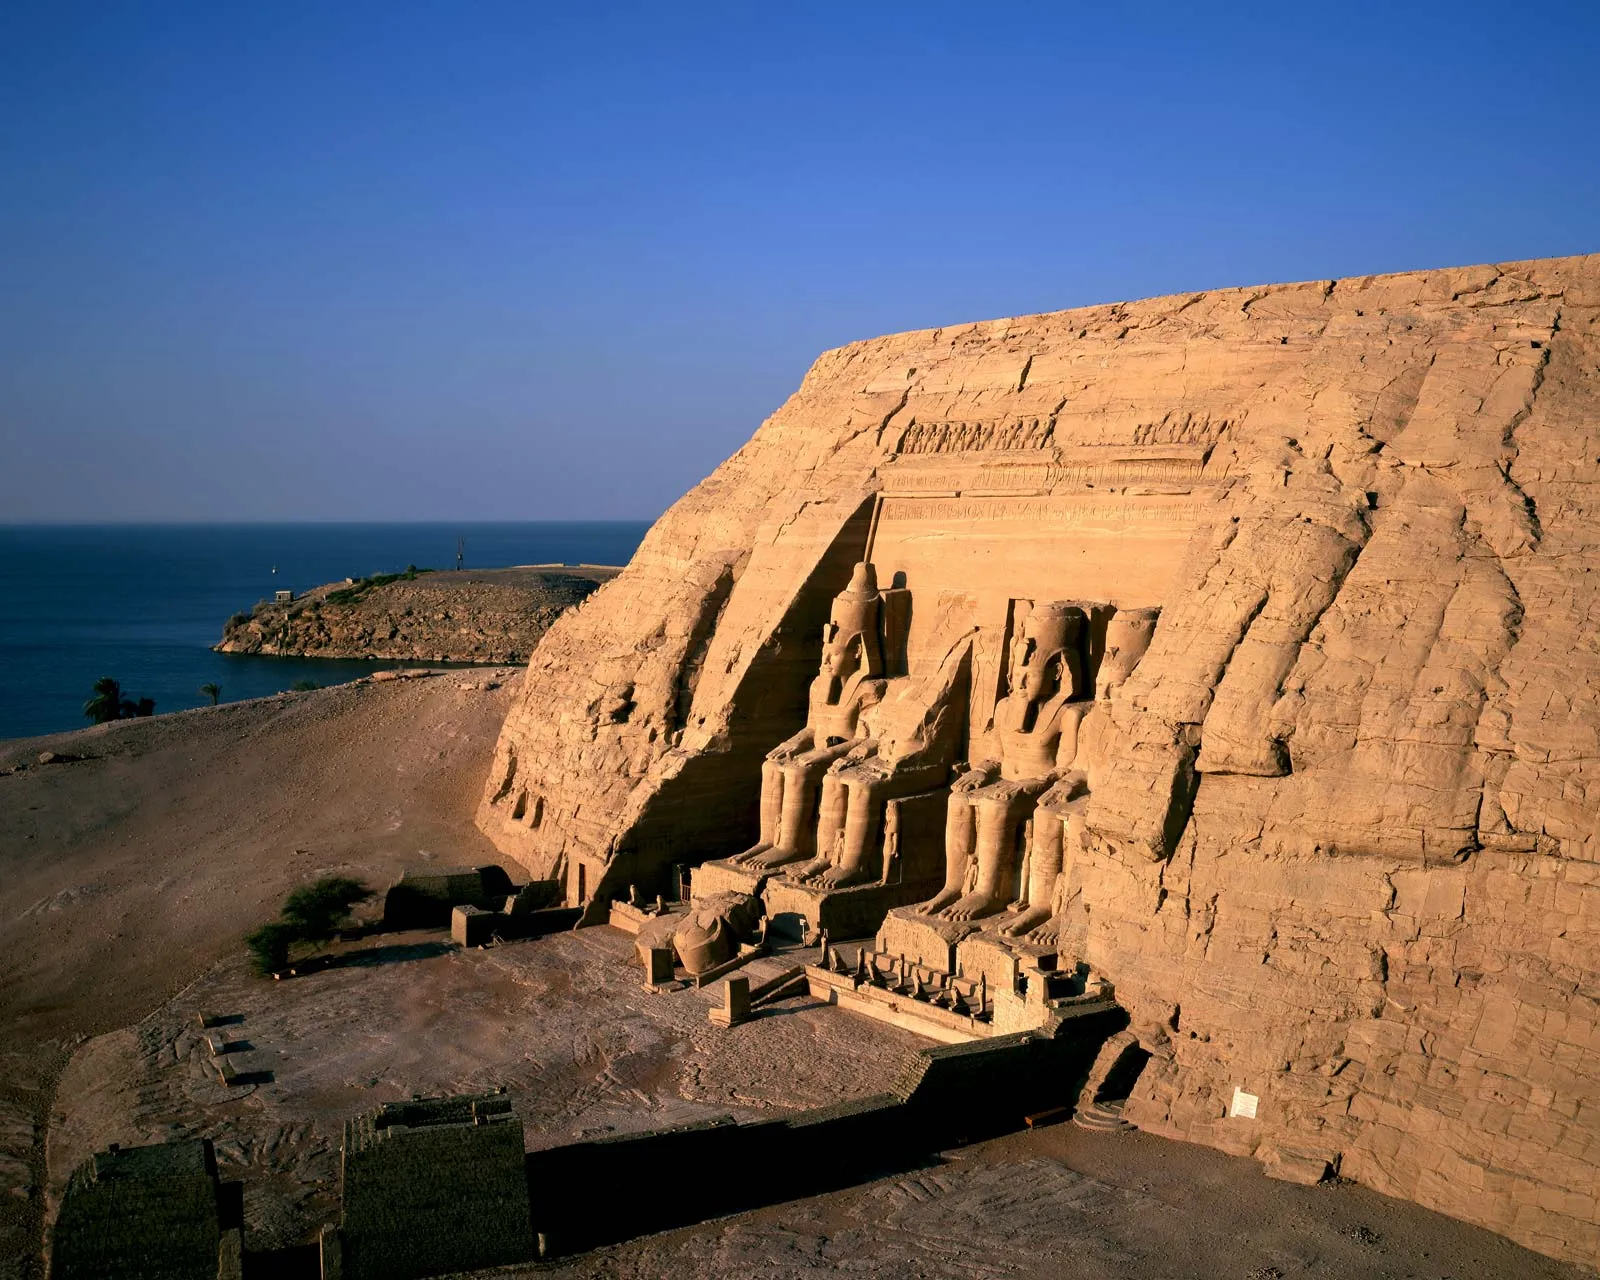Describe the historical significance of the Abu Simbel temple. The Abu Simbel temple, constructed during the reign of Pharaoh Ramesses II in the 13th century BCE, is of immense historical significance. It was built to commemorate Ramesses II's military victories, particularly the Battle of Kadesh. The temple is also a monumental testament to the pharaoh's devotion to the gods, notably Amun, Ra-Horakhty, and Ptah. Its relocation in the 1960s to save it from submersion due to the construction of the Aswan High Dam is a remarkable feat of modern engineering, highlighting its value to global heritage. The intricate carvings and inscriptions provide invaluable insights into ancient Egyptian religion, culture, and politics. What are some unique architectural features found in the Abu Simbel temple? One of the most unique architectural features of the Abu Simbel temple is its massive statues of Ramesses II, each about 20 meters high, carved directly into the rock face. Another remarkable feature is the temple's alignment with the sun: twice a year, on February 22 and October 22, sunlight penetrates the temple to illuminate the statues of the deities inside, a precision that is a testament to ancient Egyptian astronomical knowledge. The interior is adorned with detailed bas-reliefs depicting various scenes of the pharaoh's life and his divine relationship with the gods. The smaller temple dedicated to Queen Nefertari is equally impressive, featuring statues of the queen and the goddess Hathor. Imagine if the Abu Simbel temple was built by an advanced alien civilization instead of the ancient Egyptians. How would the narrative of the temple change? If the Abu Simbel temple were built by an advanced alien civilization, the narrative would shift dramatically. The colossal statues of Ramesses II might be reinterpreted as representations of the alien figures, perhaps embodying their leaders or deities. Inscriptions and carvings could be seen as alien hieroglyphs, possibly encoding advanced knowledge or messages intended for future generations. The precision of the temple's astronomical alignment might suggest advanced extraterrestrial understanding of cosmic alignments. This reinterpretation would lead to fascinating speculations about ancient astronaut theories, potentially sparking debates about the origins of human civilization and its early interactions with otherworldly beings. Can you describe a day in the life of an ancient Egyptian worker during the construction of the Abu Simbel temple? A day in the life of an ancient Egyptian worker during the construction of the Abu Simbel temple would begin before sunrise. Workers would first offer prayers and begin their day with a modest meal of bread, beer, and onions. As the first light of dawn touched the earth, they would labor under the supervision of skilled architects and artisans, chiseling the sandstone with copper tools. The rhythm of the mallets striking the stone would echo throughout the worksite. They would take short breaks to drink water and rest in the shade, overcoming the harsh desert sun. Despite the day's toil, there was a sense of pride and purpose, knowing they were part of a grand legacy. Evenings would be spent in communal settings, sharing stories and songs, before resting to prepare for another day of hard labor that contributed to this monumental project. 